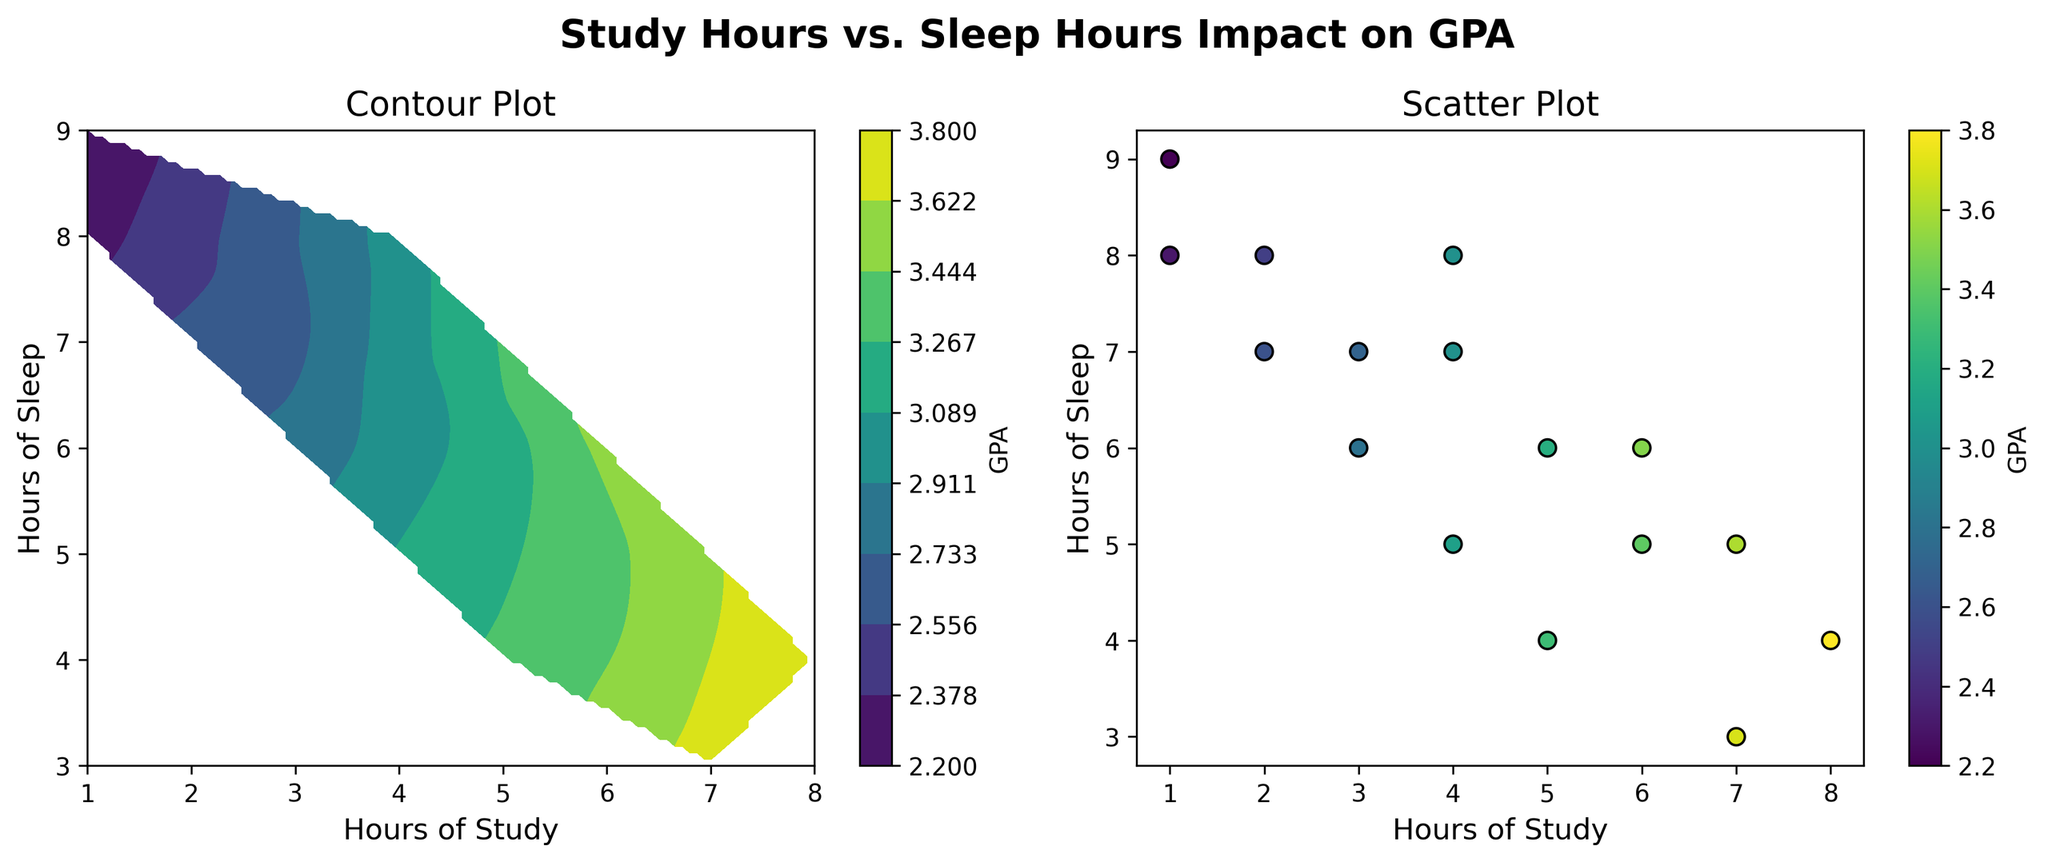What is the title of the figure? The title is located at the top center of the figure as a descriptive label to provide a summary of what the figure represents. It reads "Study Hours vs. Sleep Hours Impact on GPA".
Answer: Study Hours vs. Sleep Hours Impact on GPA What are the x-axis and y-axis labels in the contour plot? The labels on the axes help identify the variables being plotted. The x-axis is labeled "Hours of Study" and the y-axis is labeled "Hours of Sleep".
Answer: Hours of Study, Hours of Sleep How many subplots are in the figure? The figure contains two subplots, a contour plot, and a scatter plot, which are placed side by side.
Answer: Two What does the color bar in the contour plot represent? The color bar in the contour plot represents the GPA values, with different colors indicating different GPA levels.
Answer: GPA Which subplot contains individual data points represented as dots? The scatter plot subplot contains individual data points represented as dots.
Answer: Scatter plot In the contour plot, where are the highest GPA values located concerning hours of study and hours of sleep? The contour plot shows GPA values as colors, revealing that the highest GPA values are located at higher study hours (around 7-8 hours) and lower sleep hours (around 3-4 hours).
Answer: High study hours, low sleep hours Based on the scatter plot, which combination of study and sleep hours leads to the highest GPA? By observing the scatter plot, the combination of 8 hours of study and 4 hours of sleep leads to the highest GPA of 3.8.
Answer: 8 hours of study and 4 hours of sleep Compare the GPA values for students who study 3 hours and 6 hours. Who tends to have a higher GPA? By looking at the color of the dots, students who study 6 hours generally have higher GPA values than those who study 3 hours.
Answer: Students who study 6 hours Are there any data points in the scatter plot with the same GPA but different study and sleep hours? By observing the colors of the dots in the scatter plot, there are multiple GPA values that are repeated for different study and sleep hour combinations, such as a GPA of 3.0 with 4 hours of study & 7 hours of sleep and 4 hours of study & 8 hours of sleep.
Answer: Yes Does the contour plot suggest any correlation between study hours and sleep hours with GPA? The contour plot suggests that there is a positive correlation between the number of study hours and GPA and a negative correlation between sleep hours and GPA.
Answer: Yes 